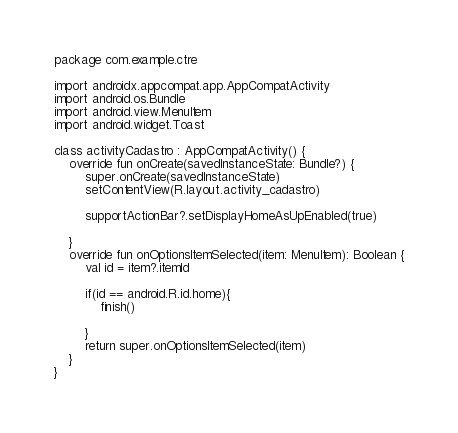Convert code to text. <code><loc_0><loc_0><loc_500><loc_500><_Kotlin_>package com.example.ctre

import androidx.appcompat.app.AppCompatActivity
import android.os.Bundle
import android.view.MenuItem
import android.widget.Toast

class activityCadastro : AppCompatActivity() {
    override fun onCreate(savedInstanceState: Bundle?) {
        super.onCreate(savedInstanceState)
        setContentView(R.layout.activity_cadastro)

        supportActionBar?.setDisplayHomeAsUpEnabled(true)

    }
    override fun onOptionsItemSelected(item: MenuItem): Boolean {
        val id = item?.itemId

        if(id == android.R.id.home){
            finish()

        }
        return super.onOptionsItemSelected(item)
    }
}</code> 